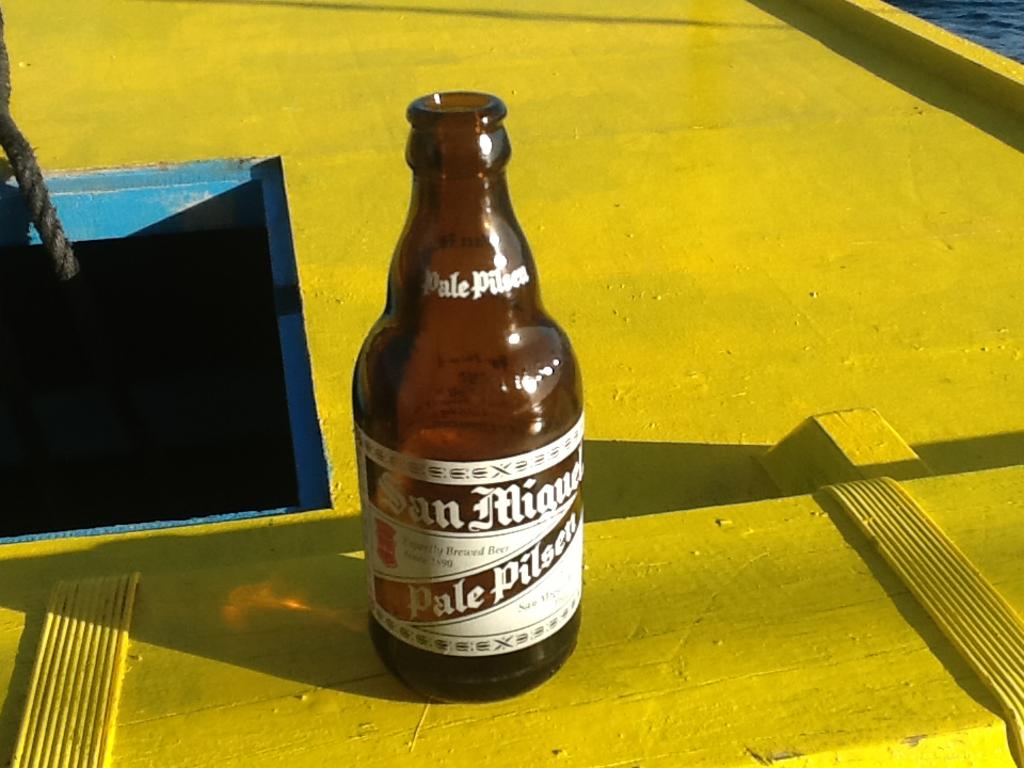What is the first word printed on the neck of this bottle?
Offer a very short reply. Pale. What kind of drink is this?
Keep it short and to the point. Pale pilsen. 